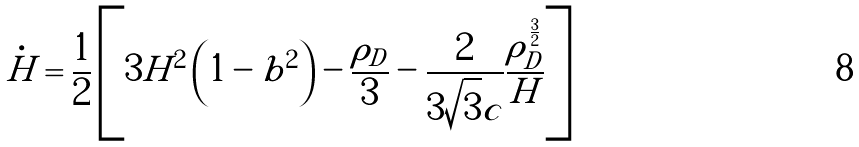<formula> <loc_0><loc_0><loc_500><loc_500>\dot { H } = \frac { 1 } { 2 } \left [ 3 H ^ { 2 } \left ( 1 - b ^ { 2 } \right ) - \frac { \rho _ { D } } { 3 } - \frac { 2 } { 3 \sqrt { 3 } c } \frac { \rho _ { D } ^ { \frac { 3 } { 2 } } } { H } \right ]</formula> 